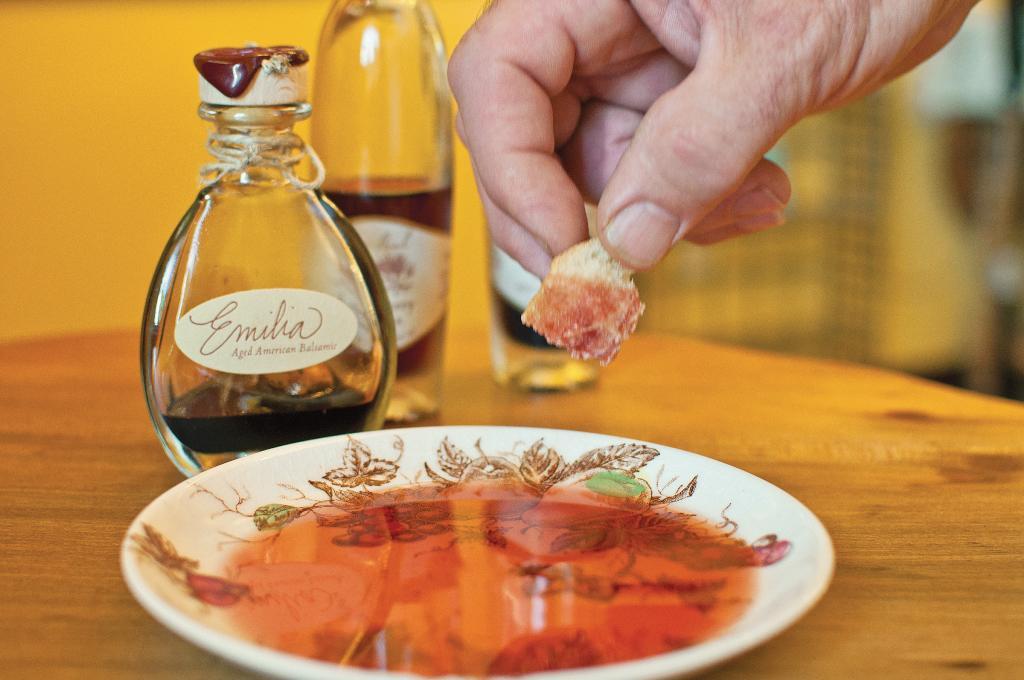What kind of vinegarette is in the bottle?
Make the answer very short. Emilia. 